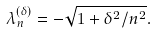Convert formula to latex. <formula><loc_0><loc_0><loc_500><loc_500>\lambda _ { n } ^ { ( \delta ) } = - \sqrt { 1 + \delta ^ { 2 } / n ^ { 2 } } .</formula> 